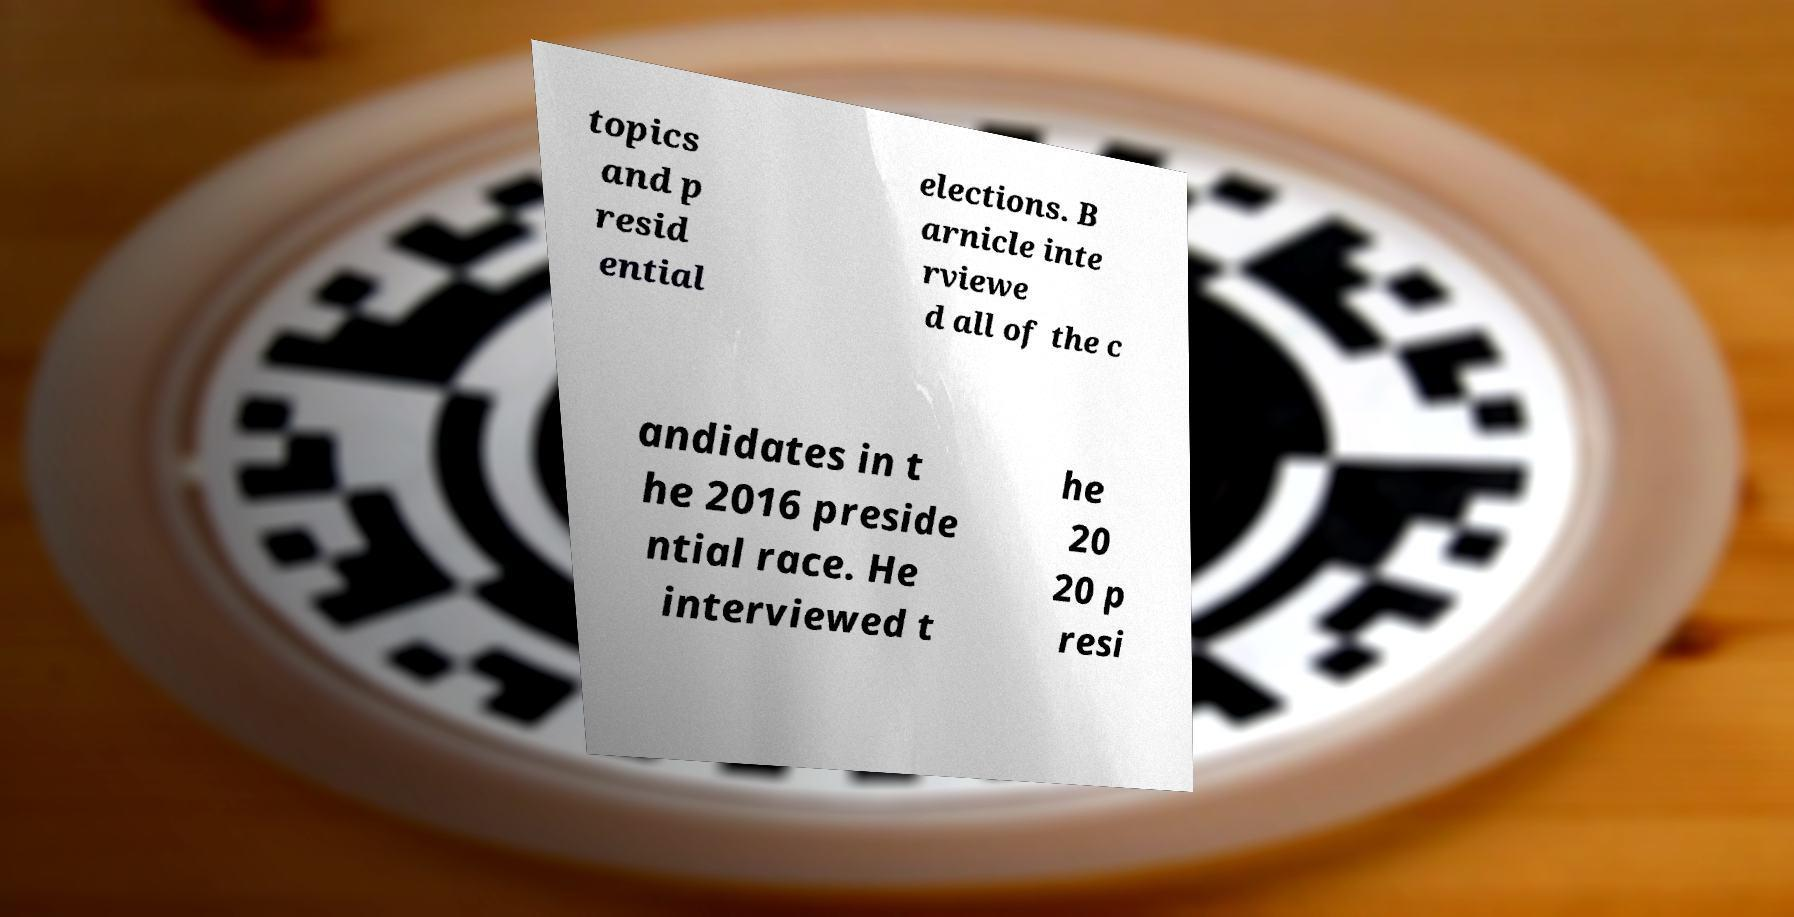What messages or text are displayed in this image? I need them in a readable, typed format. topics and p resid ential elections. B arnicle inte rviewe d all of the c andidates in t he 2016 preside ntial race. He interviewed t he 20 20 p resi 